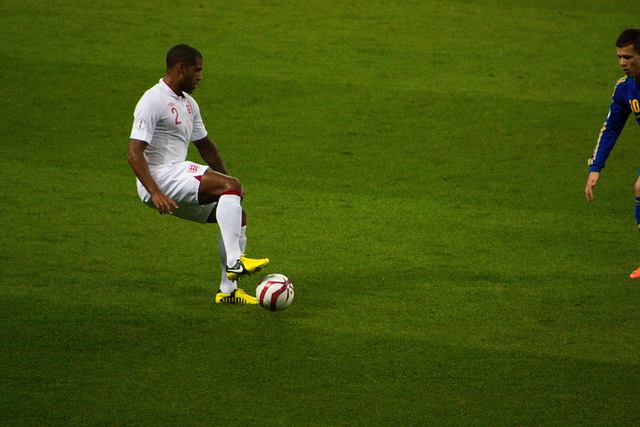<image>What is this girl doing? I don't know what the girl is doing as there are different answers like playing soccer, kicking or nothing. What is this girl doing? It is ambiguous what exactly the girl is doing. She can be just playing soccer or kicking a soccer ball. 